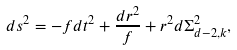<formula> <loc_0><loc_0><loc_500><loc_500>d s ^ { 2 } = - f d t ^ { 2 } + \frac { d r ^ { 2 } } { f } + r ^ { 2 } d \Sigma _ { d - 2 , k } ^ { 2 } ,</formula> 